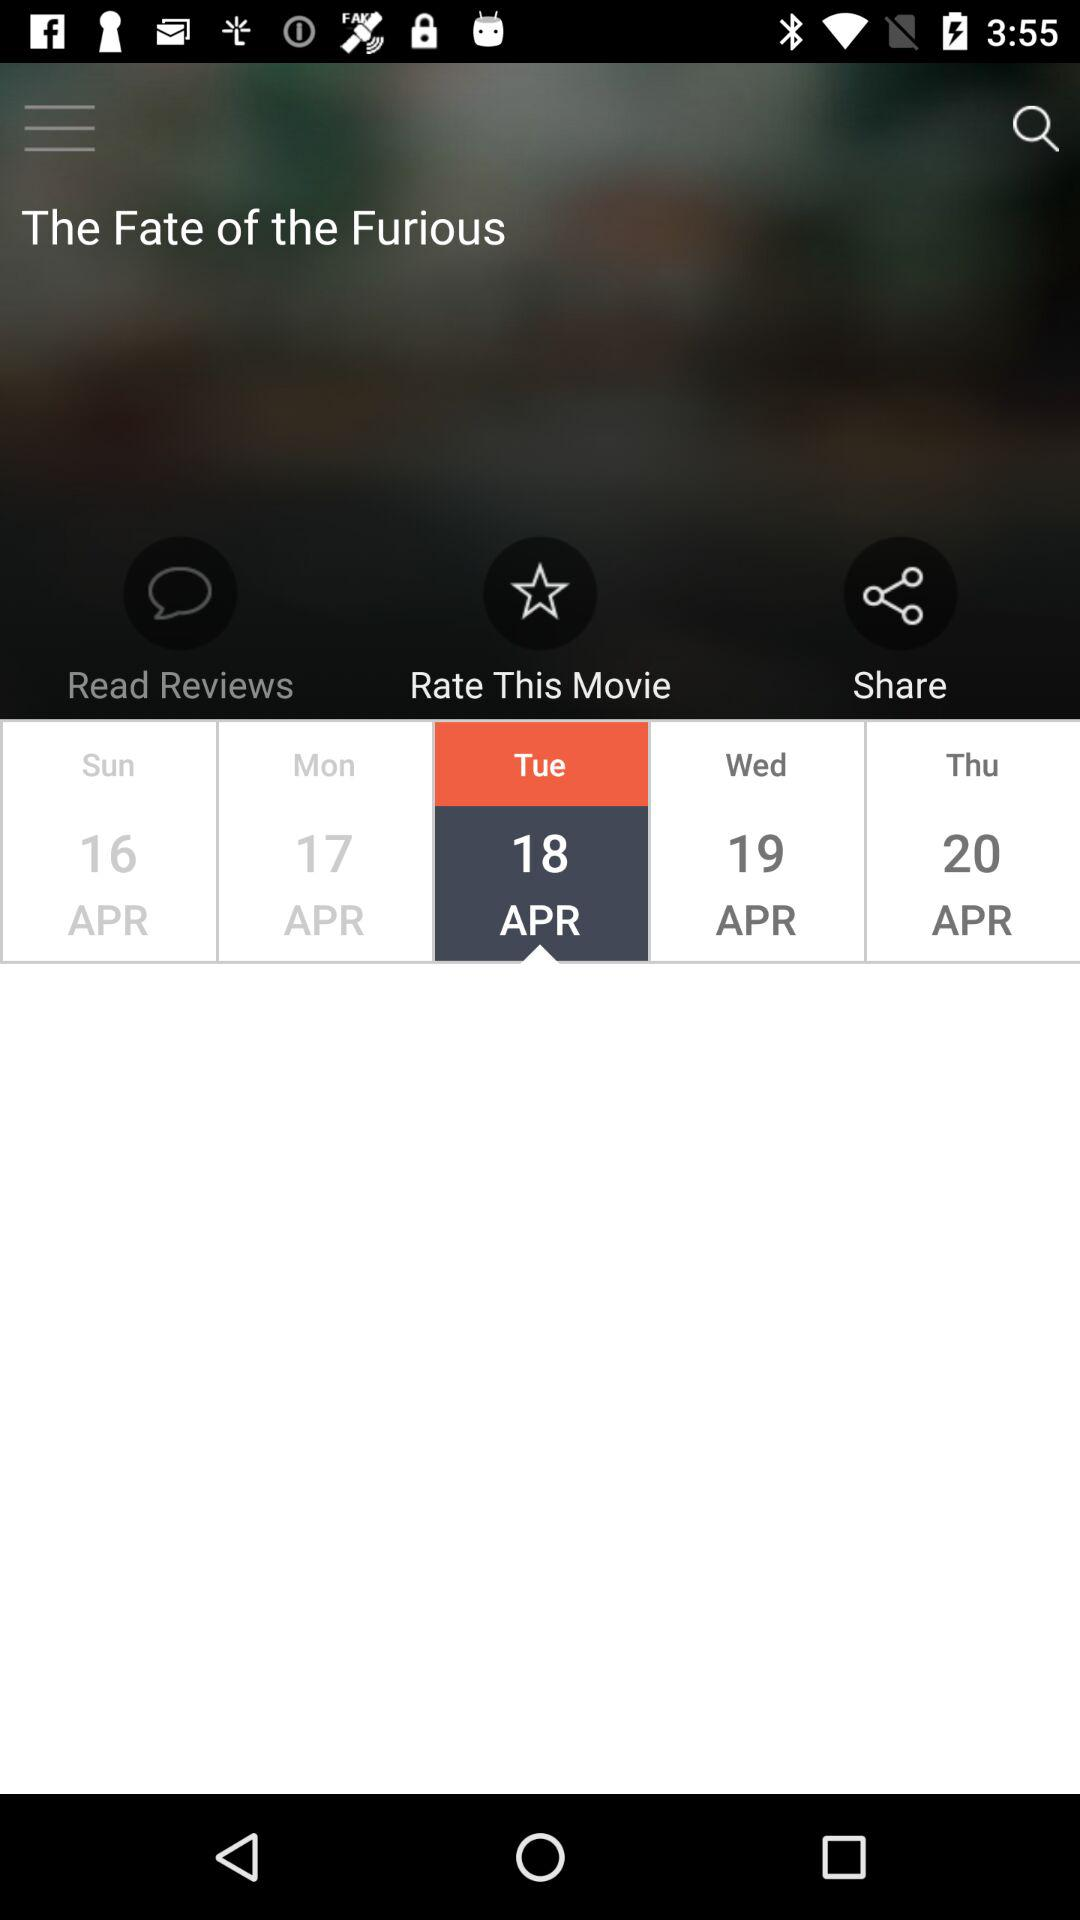Which date is selected on the calendar? The selected date is Tuesday, April 18. 